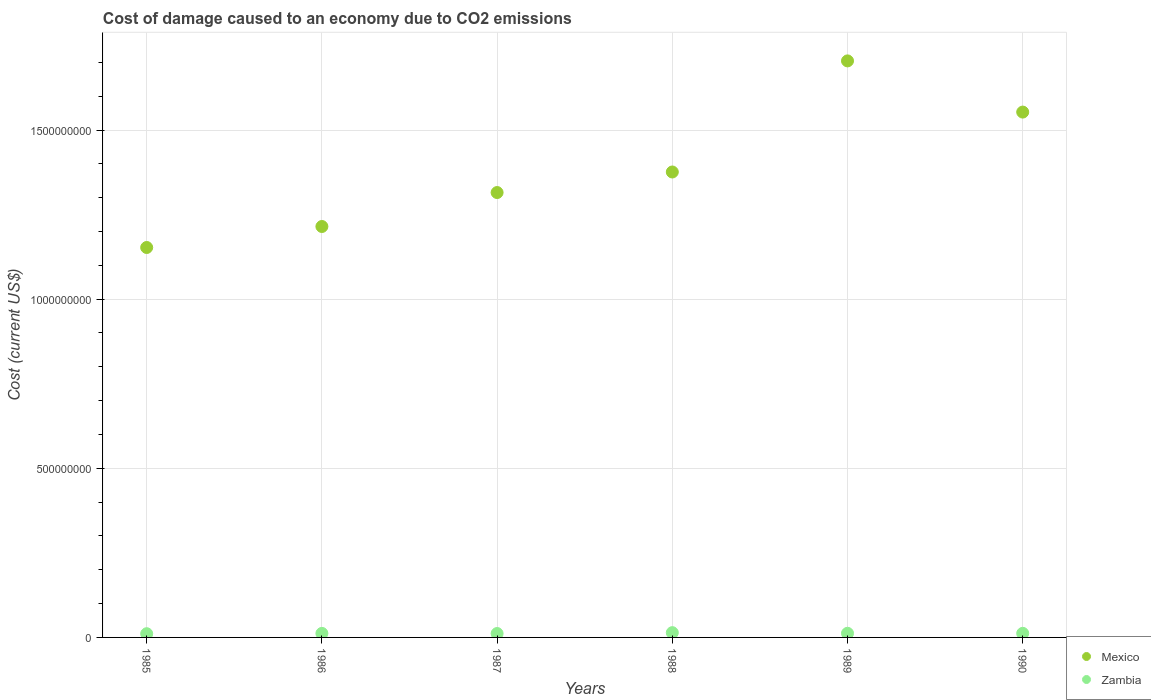Is the number of dotlines equal to the number of legend labels?
Ensure brevity in your answer.  Yes. What is the cost of damage caused due to CO2 emissisons in Mexico in 1987?
Ensure brevity in your answer.  1.32e+09. Across all years, what is the maximum cost of damage caused due to CO2 emissisons in Zambia?
Your response must be concise. 1.41e+07. Across all years, what is the minimum cost of damage caused due to CO2 emissisons in Mexico?
Your answer should be compact. 1.15e+09. In which year was the cost of damage caused due to CO2 emissisons in Zambia maximum?
Provide a succinct answer. 1988. In which year was the cost of damage caused due to CO2 emissisons in Mexico minimum?
Offer a terse response. 1985. What is the total cost of damage caused due to CO2 emissisons in Zambia in the graph?
Your answer should be compact. 7.29e+07. What is the difference between the cost of damage caused due to CO2 emissisons in Mexico in 1986 and that in 1987?
Provide a short and direct response. -1.00e+08. What is the difference between the cost of damage caused due to CO2 emissisons in Mexico in 1985 and the cost of damage caused due to CO2 emissisons in Zambia in 1989?
Make the answer very short. 1.14e+09. What is the average cost of damage caused due to CO2 emissisons in Mexico per year?
Provide a succinct answer. 1.39e+09. In the year 1986, what is the difference between the cost of damage caused due to CO2 emissisons in Mexico and cost of damage caused due to CO2 emissisons in Zambia?
Your response must be concise. 1.20e+09. In how many years, is the cost of damage caused due to CO2 emissisons in Zambia greater than 700000000 US$?
Ensure brevity in your answer.  0. What is the ratio of the cost of damage caused due to CO2 emissisons in Mexico in 1985 to that in 1989?
Provide a succinct answer. 0.68. What is the difference between the highest and the second highest cost of damage caused due to CO2 emissisons in Mexico?
Provide a succinct answer. 1.51e+08. What is the difference between the highest and the lowest cost of damage caused due to CO2 emissisons in Zambia?
Your answer should be compact. 3.08e+06. In how many years, is the cost of damage caused due to CO2 emissisons in Zambia greater than the average cost of damage caused due to CO2 emissisons in Zambia taken over all years?
Your answer should be very brief. 2. Is the sum of the cost of damage caused due to CO2 emissisons in Mexico in 1985 and 1987 greater than the maximum cost of damage caused due to CO2 emissisons in Zambia across all years?
Keep it short and to the point. Yes. Is the cost of damage caused due to CO2 emissisons in Zambia strictly greater than the cost of damage caused due to CO2 emissisons in Mexico over the years?
Offer a terse response. No. Is the cost of damage caused due to CO2 emissisons in Mexico strictly less than the cost of damage caused due to CO2 emissisons in Zambia over the years?
Make the answer very short. No. How many years are there in the graph?
Offer a very short reply. 6. What is the difference between two consecutive major ticks on the Y-axis?
Make the answer very short. 5.00e+08. Does the graph contain any zero values?
Your response must be concise. No. Does the graph contain grids?
Your answer should be very brief. Yes. Where does the legend appear in the graph?
Keep it short and to the point. Bottom right. How many legend labels are there?
Offer a very short reply. 2. How are the legend labels stacked?
Provide a short and direct response. Vertical. What is the title of the graph?
Your answer should be compact. Cost of damage caused to an economy due to CO2 emissions. What is the label or title of the Y-axis?
Your response must be concise. Cost (current US$). What is the Cost (current US$) of Mexico in 1985?
Make the answer very short. 1.15e+09. What is the Cost (current US$) in Zambia in 1985?
Keep it short and to the point. 1.10e+07. What is the Cost (current US$) of Mexico in 1986?
Your answer should be very brief. 1.21e+09. What is the Cost (current US$) in Zambia in 1986?
Make the answer very short. 1.19e+07. What is the Cost (current US$) in Mexico in 1987?
Offer a very short reply. 1.32e+09. What is the Cost (current US$) of Zambia in 1987?
Make the answer very short. 1.16e+07. What is the Cost (current US$) of Mexico in 1988?
Give a very brief answer. 1.38e+09. What is the Cost (current US$) in Zambia in 1988?
Keep it short and to the point. 1.41e+07. What is the Cost (current US$) in Mexico in 1989?
Ensure brevity in your answer.  1.70e+09. What is the Cost (current US$) of Zambia in 1989?
Provide a short and direct response. 1.23e+07. What is the Cost (current US$) of Mexico in 1990?
Keep it short and to the point. 1.55e+09. What is the Cost (current US$) of Zambia in 1990?
Offer a very short reply. 1.21e+07. Across all years, what is the maximum Cost (current US$) in Mexico?
Offer a very short reply. 1.70e+09. Across all years, what is the maximum Cost (current US$) of Zambia?
Give a very brief answer. 1.41e+07. Across all years, what is the minimum Cost (current US$) of Mexico?
Your response must be concise. 1.15e+09. Across all years, what is the minimum Cost (current US$) of Zambia?
Provide a succinct answer. 1.10e+07. What is the total Cost (current US$) of Mexico in the graph?
Offer a very short reply. 8.32e+09. What is the total Cost (current US$) in Zambia in the graph?
Ensure brevity in your answer.  7.29e+07. What is the difference between the Cost (current US$) in Mexico in 1985 and that in 1986?
Ensure brevity in your answer.  -6.21e+07. What is the difference between the Cost (current US$) of Zambia in 1985 and that in 1986?
Offer a terse response. -9.13e+05. What is the difference between the Cost (current US$) of Mexico in 1985 and that in 1987?
Offer a very short reply. -1.62e+08. What is the difference between the Cost (current US$) in Zambia in 1985 and that in 1987?
Give a very brief answer. -5.61e+05. What is the difference between the Cost (current US$) of Mexico in 1985 and that in 1988?
Your response must be concise. -2.23e+08. What is the difference between the Cost (current US$) of Zambia in 1985 and that in 1988?
Your answer should be very brief. -3.08e+06. What is the difference between the Cost (current US$) of Mexico in 1985 and that in 1989?
Ensure brevity in your answer.  -5.52e+08. What is the difference between the Cost (current US$) of Zambia in 1985 and that in 1989?
Offer a terse response. -1.26e+06. What is the difference between the Cost (current US$) in Mexico in 1985 and that in 1990?
Your answer should be very brief. -4.00e+08. What is the difference between the Cost (current US$) in Zambia in 1985 and that in 1990?
Make the answer very short. -1.08e+06. What is the difference between the Cost (current US$) in Mexico in 1986 and that in 1987?
Your answer should be very brief. -1.00e+08. What is the difference between the Cost (current US$) of Zambia in 1986 and that in 1987?
Keep it short and to the point. 3.53e+05. What is the difference between the Cost (current US$) in Mexico in 1986 and that in 1988?
Offer a very short reply. -1.61e+08. What is the difference between the Cost (current US$) of Zambia in 1986 and that in 1988?
Your answer should be compact. -2.16e+06. What is the difference between the Cost (current US$) of Mexico in 1986 and that in 1989?
Ensure brevity in your answer.  -4.90e+08. What is the difference between the Cost (current US$) in Zambia in 1986 and that in 1989?
Make the answer very short. -3.45e+05. What is the difference between the Cost (current US$) of Mexico in 1986 and that in 1990?
Provide a short and direct response. -3.38e+08. What is the difference between the Cost (current US$) of Zambia in 1986 and that in 1990?
Provide a short and direct response. -1.69e+05. What is the difference between the Cost (current US$) in Mexico in 1987 and that in 1988?
Offer a very short reply. -6.07e+07. What is the difference between the Cost (current US$) in Zambia in 1987 and that in 1988?
Provide a succinct answer. -2.52e+06. What is the difference between the Cost (current US$) in Mexico in 1987 and that in 1989?
Your response must be concise. -3.89e+08. What is the difference between the Cost (current US$) in Zambia in 1987 and that in 1989?
Offer a terse response. -6.98e+05. What is the difference between the Cost (current US$) in Mexico in 1987 and that in 1990?
Provide a short and direct response. -2.38e+08. What is the difference between the Cost (current US$) in Zambia in 1987 and that in 1990?
Your response must be concise. -5.22e+05. What is the difference between the Cost (current US$) of Mexico in 1988 and that in 1989?
Your answer should be compact. -3.28e+08. What is the difference between the Cost (current US$) in Zambia in 1988 and that in 1989?
Provide a succinct answer. 1.82e+06. What is the difference between the Cost (current US$) of Mexico in 1988 and that in 1990?
Provide a short and direct response. -1.77e+08. What is the difference between the Cost (current US$) in Zambia in 1988 and that in 1990?
Offer a very short reply. 2.00e+06. What is the difference between the Cost (current US$) in Mexico in 1989 and that in 1990?
Offer a terse response. 1.51e+08. What is the difference between the Cost (current US$) in Zambia in 1989 and that in 1990?
Ensure brevity in your answer.  1.76e+05. What is the difference between the Cost (current US$) of Mexico in 1985 and the Cost (current US$) of Zambia in 1986?
Ensure brevity in your answer.  1.14e+09. What is the difference between the Cost (current US$) in Mexico in 1985 and the Cost (current US$) in Zambia in 1987?
Give a very brief answer. 1.14e+09. What is the difference between the Cost (current US$) of Mexico in 1985 and the Cost (current US$) of Zambia in 1988?
Your response must be concise. 1.14e+09. What is the difference between the Cost (current US$) of Mexico in 1985 and the Cost (current US$) of Zambia in 1989?
Offer a very short reply. 1.14e+09. What is the difference between the Cost (current US$) of Mexico in 1985 and the Cost (current US$) of Zambia in 1990?
Ensure brevity in your answer.  1.14e+09. What is the difference between the Cost (current US$) of Mexico in 1986 and the Cost (current US$) of Zambia in 1987?
Give a very brief answer. 1.20e+09. What is the difference between the Cost (current US$) in Mexico in 1986 and the Cost (current US$) in Zambia in 1988?
Give a very brief answer. 1.20e+09. What is the difference between the Cost (current US$) of Mexico in 1986 and the Cost (current US$) of Zambia in 1989?
Provide a succinct answer. 1.20e+09. What is the difference between the Cost (current US$) in Mexico in 1986 and the Cost (current US$) in Zambia in 1990?
Ensure brevity in your answer.  1.20e+09. What is the difference between the Cost (current US$) of Mexico in 1987 and the Cost (current US$) of Zambia in 1988?
Keep it short and to the point. 1.30e+09. What is the difference between the Cost (current US$) of Mexico in 1987 and the Cost (current US$) of Zambia in 1989?
Offer a very short reply. 1.30e+09. What is the difference between the Cost (current US$) of Mexico in 1987 and the Cost (current US$) of Zambia in 1990?
Your response must be concise. 1.30e+09. What is the difference between the Cost (current US$) of Mexico in 1988 and the Cost (current US$) of Zambia in 1989?
Your answer should be very brief. 1.36e+09. What is the difference between the Cost (current US$) in Mexico in 1988 and the Cost (current US$) in Zambia in 1990?
Your answer should be very brief. 1.36e+09. What is the difference between the Cost (current US$) of Mexico in 1989 and the Cost (current US$) of Zambia in 1990?
Your answer should be very brief. 1.69e+09. What is the average Cost (current US$) in Mexico per year?
Your answer should be compact. 1.39e+09. What is the average Cost (current US$) of Zambia per year?
Your answer should be very brief. 1.22e+07. In the year 1985, what is the difference between the Cost (current US$) of Mexico and Cost (current US$) of Zambia?
Your answer should be very brief. 1.14e+09. In the year 1986, what is the difference between the Cost (current US$) in Mexico and Cost (current US$) in Zambia?
Make the answer very short. 1.20e+09. In the year 1987, what is the difference between the Cost (current US$) in Mexico and Cost (current US$) in Zambia?
Your answer should be compact. 1.30e+09. In the year 1988, what is the difference between the Cost (current US$) of Mexico and Cost (current US$) of Zambia?
Offer a very short reply. 1.36e+09. In the year 1989, what is the difference between the Cost (current US$) of Mexico and Cost (current US$) of Zambia?
Offer a very short reply. 1.69e+09. In the year 1990, what is the difference between the Cost (current US$) of Mexico and Cost (current US$) of Zambia?
Make the answer very short. 1.54e+09. What is the ratio of the Cost (current US$) of Mexico in 1985 to that in 1986?
Provide a short and direct response. 0.95. What is the ratio of the Cost (current US$) of Zambia in 1985 to that in 1986?
Your answer should be compact. 0.92. What is the ratio of the Cost (current US$) of Mexico in 1985 to that in 1987?
Your response must be concise. 0.88. What is the ratio of the Cost (current US$) of Zambia in 1985 to that in 1987?
Your response must be concise. 0.95. What is the ratio of the Cost (current US$) of Mexico in 1985 to that in 1988?
Offer a very short reply. 0.84. What is the ratio of the Cost (current US$) of Zambia in 1985 to that in 1988?
Your answer should be compact. 0.78. What is the ratio of the Cost (current US$) of Mexico in 1985 to that in 1989?
Your answer should be compact. 0.68. What is the ratio of the Cost (current US$) in Zambia in 1985 to that in 1989?
Provide a succinct answer. 0.9. What is the ratio of the Cost (current US$) of Mexico in 1985 to that in 1990?
Keep it short and to the point. 0.74. What is the ratio of the Cost (current US$) of Zambia in 1985 to that in 1990?
Ensure brevity in your answer.  0.91. What is the ratio of the Cost (current US$) of Mexico in 1986 to that in 1987?
Your answer should be compact. 0.92. What is the ratio of the Cost (current US$) of Zambia in 1986 to that in 1987?
Your answer should be very brief. 1.03. What is the ratio of the Cost (current US$) in Mexico in 1986 to that in 1988?
Ensure brevity in your answer.  0.88. What is the ratio of the Cost (current US$) in Zambia in 1986 to that in 1988?
Offer a very short reply. 0.85. What is the ratio of the Cost (current US$) of Mexico in 1986 to that in 1989?
Your answer should be very brief. 0.71. What is the ratio of the Cost (current US$) of Zambia in 1986 to that in 1989?
Keep it short and to the point. 0.97. What is the ratio of the Cost (current US$) of Mexico in 1986 to that in 1990?
Offer a terse response. 0.78. What is the ratio of the Cost (current US$) of Mexico in 1987 to that in 1988?
Make the answer very short. 0.96. What is the ratio of the Cost (current US$) of Zambia in 1987 to that in 1988?
Keep it short and to the point. 0.82. What is the ratio of the Cost (current US$) of Mexico in 1987 to that in 1989?
Provide a short and direct response. 0.77. What is the ratio of the Cost (current US$) in Zambia in 1987 to that in 1989?
Ensure brevity in your answer.  0.94. What is the ratio of the Cost (current US$) of Mexico in 1987 to that in 1990?
Your response must be concise. 0.85. What is the ratio of the Cost (current US$) in Zambia in 1987 to that in 1990?
Offer a very short reply. 0.96. What is the ratio of the Cost (current US$) of Mexico in 1988 to that in 1989?
Provide a succinct answer. 0.81. What is the ratio of the Cost (current US$) in Zambia in 1988 to that in 1989?
Your response must be concise. 1.15. What is the ratio of the Cost (current US$) of Mexico in 1988 to that in 1990?
Ensure brevity in your answer.  0.89. What is the ratio of the Cost (current US$) in Zambia in 1988 to that in 1990?
Make the answer very short. 1.17. What is the ratio of the Cost (current US$) of Mexico in 1989 to that in 1990?
Give a very brief answer. 1.1. What is the ratio of the Cost (current US$) in Zambia in 1989 to that in 1990?
Provide a succinct answer. 1.01. What is the difference between the highest and the second highest Cost (current US$) of Mexico?
Provide a succinct answer. 1.51e+08. What is the difference between the highest and the second highest Cost (current US$) of Zambia?
Give a very brief answer. 1.82e+06. What is the difference between the highest and the lowest Cost (current US$) of Mexico?
Offer a very short reply. 5.52e+08. What is the difference between the highest and the lowest Cost (current US$) of Zambia?
Keep it short and to the point. 3.08e+06. 